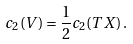Convert formula to latex. <formula><loc_0><loc_0><loc_500><loc_500>c _ { 2 } ( V ) = \frac { 1 } { 2 } c _ { 2 } ( T X ) \, .</formula> 